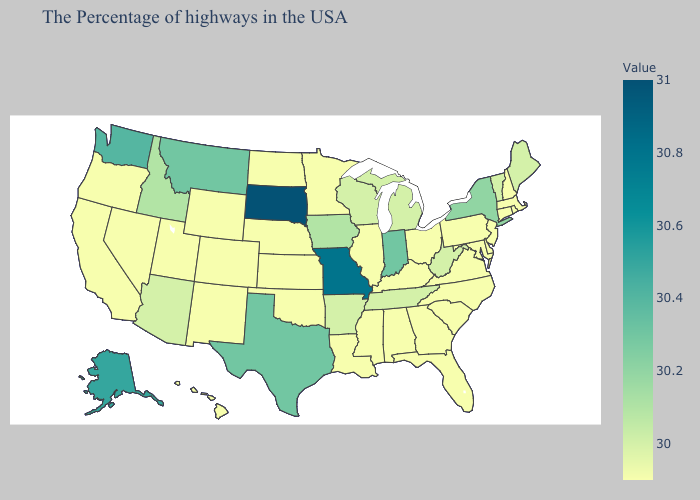Does Nebraska have the highest value in the USA?
Give a very brief answer. No. Among the states that border California , does Arizona have the highest value?
Give a very brief answer. Yes. Does Georgia have the lowest value in the South?
Quick response, please. Yes. Does Vermont have the highest value in the USA?
Write a very short answer. No. Does Oklahoma have the highest value in the USA?
Short answer required. No. Among the states that border Iowa , which have the highest value?
Quick response, please. South Dakota. 